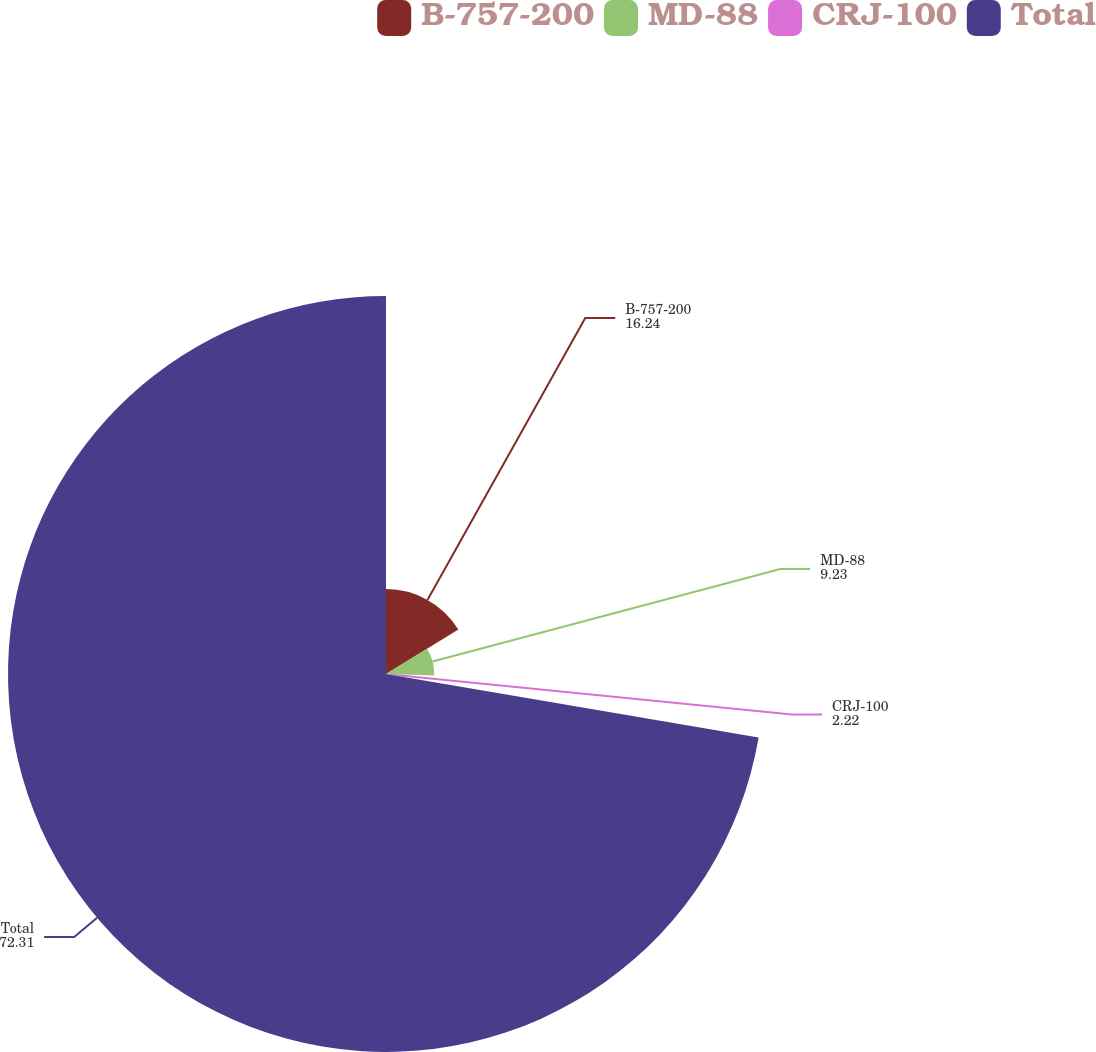<chart> <loc_0><loc_0><loc_500><loc_500><pie_chart><fcel>B-757-200<fcel>MD-88<fcel>CRJ-100<fcel>Total<nl><fcel>16.24%<fcel>9.23%<fcel>2.22%<fcel>72.31%<nl></chart> 